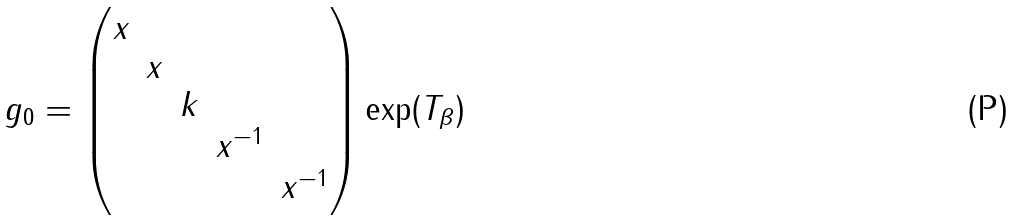Convert formula to latex. <formula><loc_0><loc_0><loc_500><loc_500>g _ { 0 } = \begin{pmatrix} x & & & & \\ & x & & & \\ & & k & & \\ & & & x ^ { - 1 } & \\ & & & & x ^ { - 1 } \end{pmatrix} \exp ( T _ { \beta } )</formula> 